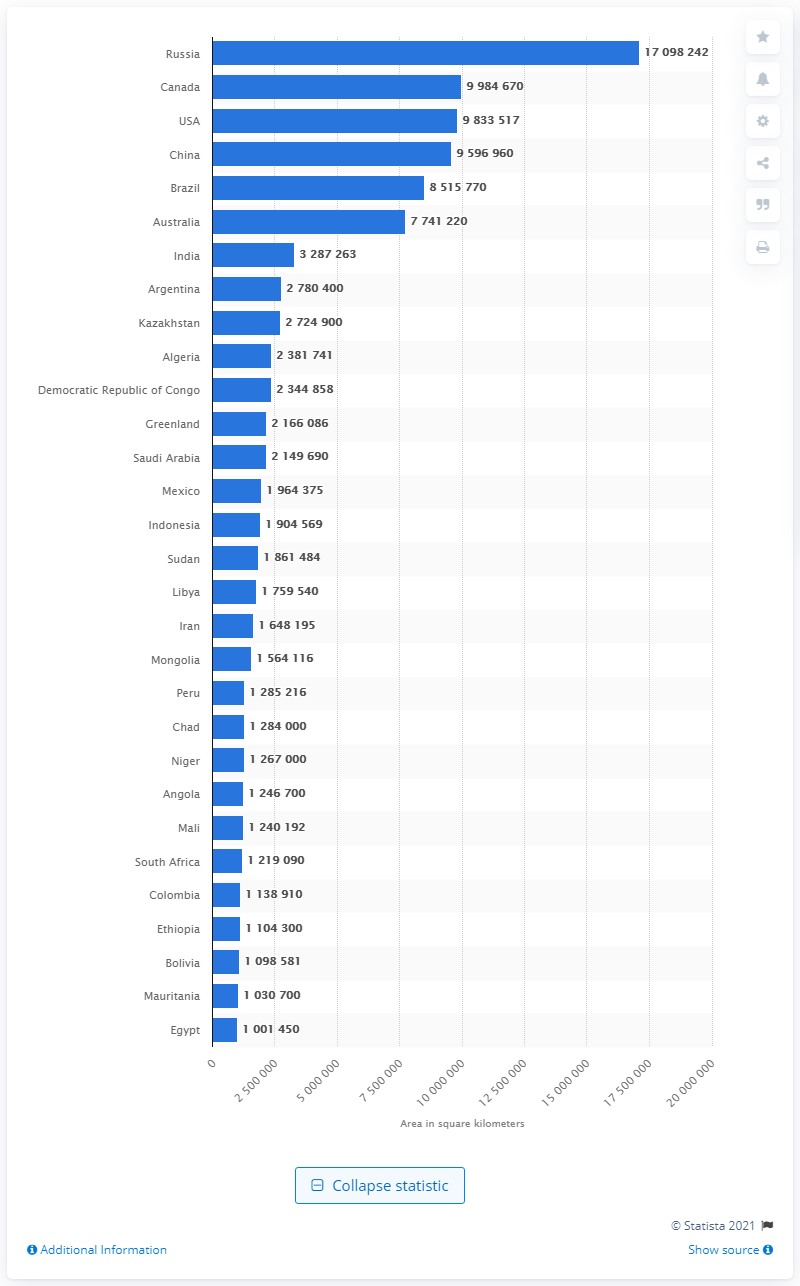List a handful of essential elements in this visual. According to official statistics, Russia's total area is 17,098,242 square kilometers. Russia is the largest country in the world by area. 